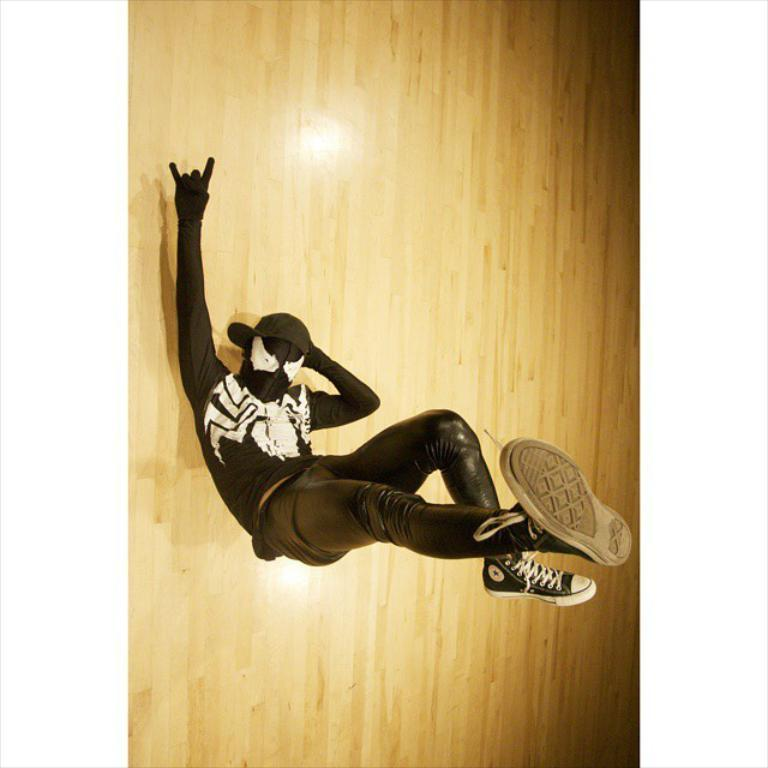What is the position of the man in the image? The man is laying on his back in the image. What is the man doing with his legs? The man has lifted his legs off the ground in the image. What is the man wearing on his head? The man is wearing a cap on his head in the image. What is the man wearing on his face? The man is wearing a mask on his face in the image. What color is the dress the man is wearing? The man is wearing a black color dress in the image. What type of texture can be seen on the desk in the image? There is no desk present in the image; it features a man laying on his back with his legs lifted off the ground. 